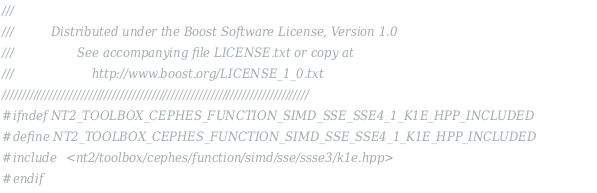Convert code to text. <code><loc_0><loc_0><loc_500><loc_500><_C++_>///
///          Distributed under the Boost Software License, Version 1.0
///                 See accompanying file LICENSE.txt or copy at
///                     http://www.boost.org/LICENSE_1_0.txt
//////////////////////////////////////////////////////////////////////////////
#ifndef NT2_TOOLBOX_CEPHES_FUNCTION_SIMD_SSE_SSE4_1_K1E_HPP_INCLUDED
#define NT2_TOOLBOX_CEPHES_FUNCTION_SIMD_SSE_SSE4_1_K1E_HPP_INCLUDED
#include <nt2/toolbox/cephes/function/simd/sse/ssse3/k1e.hpp>
#endif
</code> 